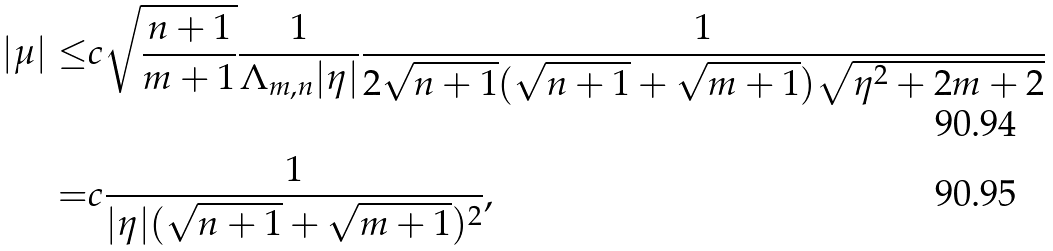<formula> <loc_0><loc_0><loc_500><loc_500>| \mu | \leq & c \sqrt { \frac { n + 1 } { m + 1 } } \frac { 1 } { \Lambda _ { m , n } | \eta | } \frac { 1 } { 2 \sqrt { n + 1 } ( \sqrt { n + 1 } + \sqrt { m + 1 } ) \sqrt { \eta ^ { 2 } + 2 m + 2 } } \\ = & c \frac { 1 } { | \eta | ( \sqrt { n + 1 } + \sqrt { m + 1 } ) ^ { 2 } } ,</formula> 